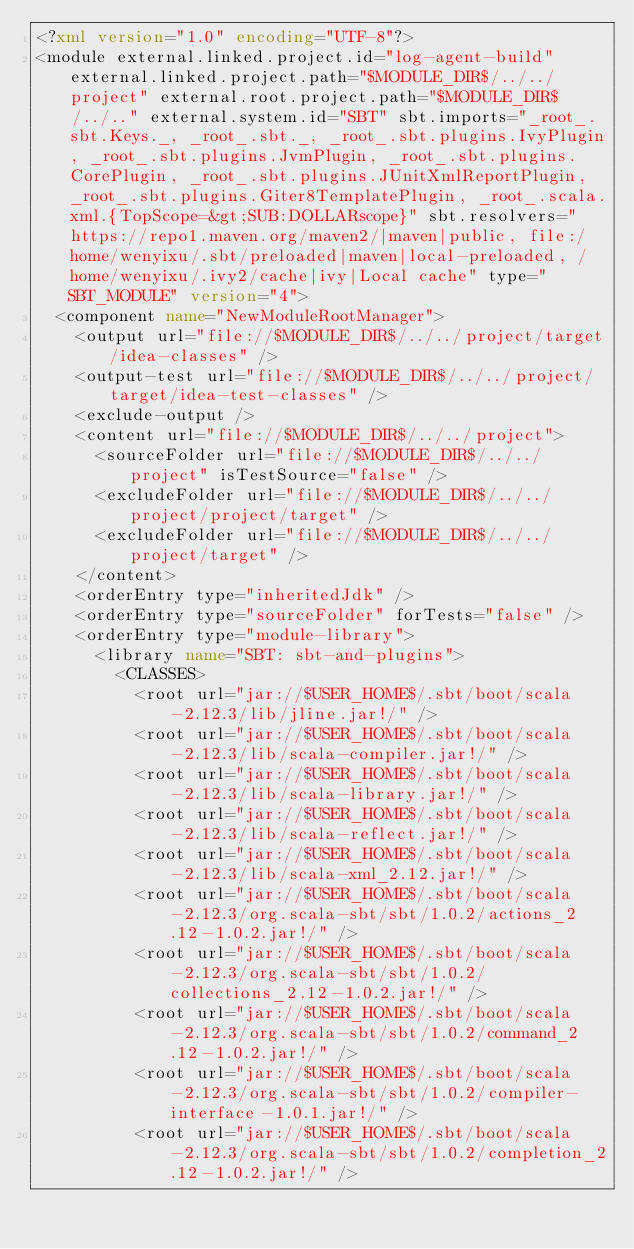Convert code to text. <code><loc_0><loc_0><loc_500><loc_500><_XML_><?xml version="1.0" encoding="UTF-8"?>
<module external.linked.project.id="log-agent-build" external.linked.project.path="$MODULE_DIR$/../../project" external.root.project.path="$MODULE_DIR$/../.." external.system.id="SBT" sbt.imports="_root_.sbt.Keys._, _root_.sbt._, _root_.sbt.plugins.IvyPlugin, _root_.sbt.plugins.JvmPlugin, _root_.sbt.plugins.CorePlugin, _root_.sbt.plugins.JUnitXmlReportPlugin, _root_.sbt.plugins.Giter8TemplatePlugin, _root_.scala.xml.{TopScope=&gt;SUB:DOLLARscope}" sbt.resolvers="https://repo1.maven.org/maven2/|maven|public, file:/home/wenyixu/.sbt/preloaded|maven|local-preloaded, /home/wenyixu/.ivy2/cache|ivy|Local cache" type="SBT_MODULE" version="4">
  <component name="NewModuleRootManager">
    <output url="file://$MODULE_DIR$/../../project/target/idea-classes" />
    <output-test url="file://$MODULE_DIR$/../../project/target/idea-test-classes" />
    <exclude-output />
    <content url="file://$MODULE_DIR$/../../project">
      <sourceFolder url="file://$MODULE_DIR$/../../project" isTestSource="false" />
      <excludeFolder url="file://$MODULE_DIR$/../../project/project/target" />
      <excludeFolder url="file://$MODULE_DIR$/../../project/target" />
    </content>
    <orderEntry type="inheritedJdk" />
    <orderEntry type="sourceFolder" forTests="false" />
    <orderEntry type="module-library">
      <library name="SBT: sbt-and-plugins">
        <CLASSES>
          <root url="jar://$USER_HOME$/.sbt/boot/scala-2.12.3/lib/jline.jar!/" />
          <root url="jar://$USER_HOME$/.sbt/boot/scala-2.12.3/lib/scala-compiler.jar!/" />
          <root url="jar://$USER_HOME$/.sbt/boot/scala-2.12.3/lib/scala-library.jar!/" />
          <root url="jar://$USER_HOME$/.sbt/boot/scala-2.12.3/lib/scala-reflect.jar!/" />
          <root url="jar://$USER_HOME$/.sbt/boot/scala-2.12.3/lib/scala-xml_2.12.jar!/" />
          <root url="jar://$USER_HOME$/.sbt/boot/scala-2.12.3/org.scala-sbt/sbt/1.0.2/actions_2.12-1.0.2.jar!/" />
          <root url="jar://$USER_HOME$/.sbt/boot/scala-2.12.3/org.scala-sbt/sbt/1.0.2/collections_2.12-1.0.2.jar!/" />
          <root url="jar://$USER_HOME$/.sbt/boot/scala-2.12.3/org.scala-sbt/sbt/1.0.2/command_2.12-1.0.2.jar!/" />
          <root url="jar://$USER_HOME$/.sbt/boot/scala-2.12.3/org.scala-sbt/sbt/1.0.2/compiler-interface-1.0.1.jar!/" />
          <root url="jar://$USER_HOME$/.sbt/boot/scala-2.12.3/org.scala-sbt/sbt/1.0.2/completion_2.12-1.0.2.jar!/" /></code> 